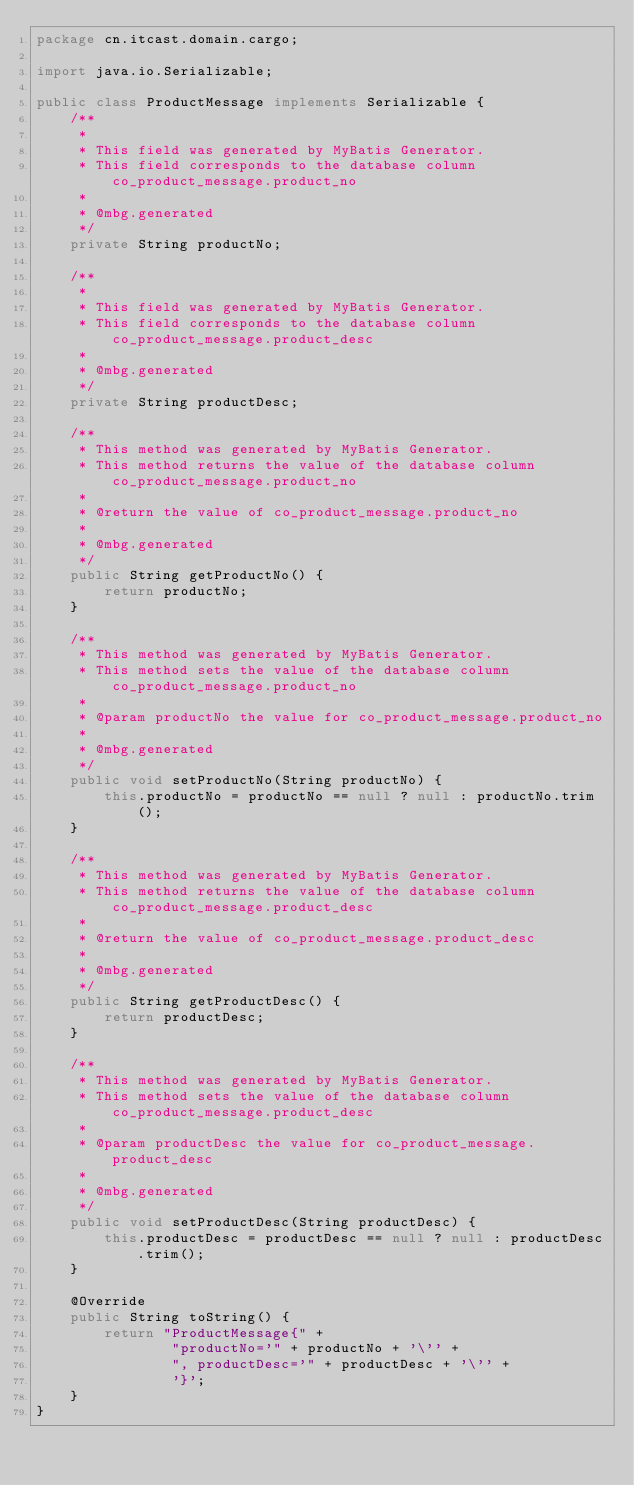<code> <loc_0><loc_0><loc_500><loc_500><_Java_>package cn.itcast.domain.cargo;

import java.io.Serializable;

public class ProductMessage implements Serializable {
    /**
     *
     * This field was generated by MyBatis Generator.
     * This field corresponds to the database column co_product_message.product_no
     *
     * @mbg.generated
     */
    private String productNo;

    /**
     *
     * This field was generated by MyBatis Generator.
     * This field corresponds to the database column co_product_message.product_desc
     *
     * @mbg.generated
     */
    private String productDesc;

    /**
     * This method was generated by MyBatis Generator.
     * This method returns the value of the database column co_product_message.product_no
     *
     * @return the value of co_product_message.product_no
     *
     * @mbg.generated
     */
    public String getProductNo() {
        return productNo;
    }

    /**
     * This method was generated by MyBatis Generator.
     * This method sets the value of the database column co_product_message.product_no
     *
     * @param productNo the value for co_product_message.product_no
     *
     * @mbg.generated
     */
    public void setProductNo(String productNo) {
        this.productNo = productNo == null ? null : productNo.trim();
    }

    /**
     * This method was generated by MyBatis Generator.
     * This method returns the value of the database column co_product_message.product_desc
     *
     * @return the value of co_product_message.product_desc
     *
     * @mbg.generated
     */
    public String getProductDesc() {
        return productDesc;
    }

    /**
     * This method was generated by MyBatis Generator.
     * This method sets the value of the database column co_product_message.product_desc
     *
     * @param productDesc the value for co_product_message.product_desc
     *
     * @mbg.generated
     */
    public void setProductDesc(String productDesc) {
        this.productDesc = productDesc == null ? null : productDesc.trim();
    }

    @Override
    public String toString() {
        return "ProductMessage{" +
                "productNo='" + productNo + '\'' +
                ", productDesc='" + productDesc + '\'' +
                '}';
    }
}</code> 